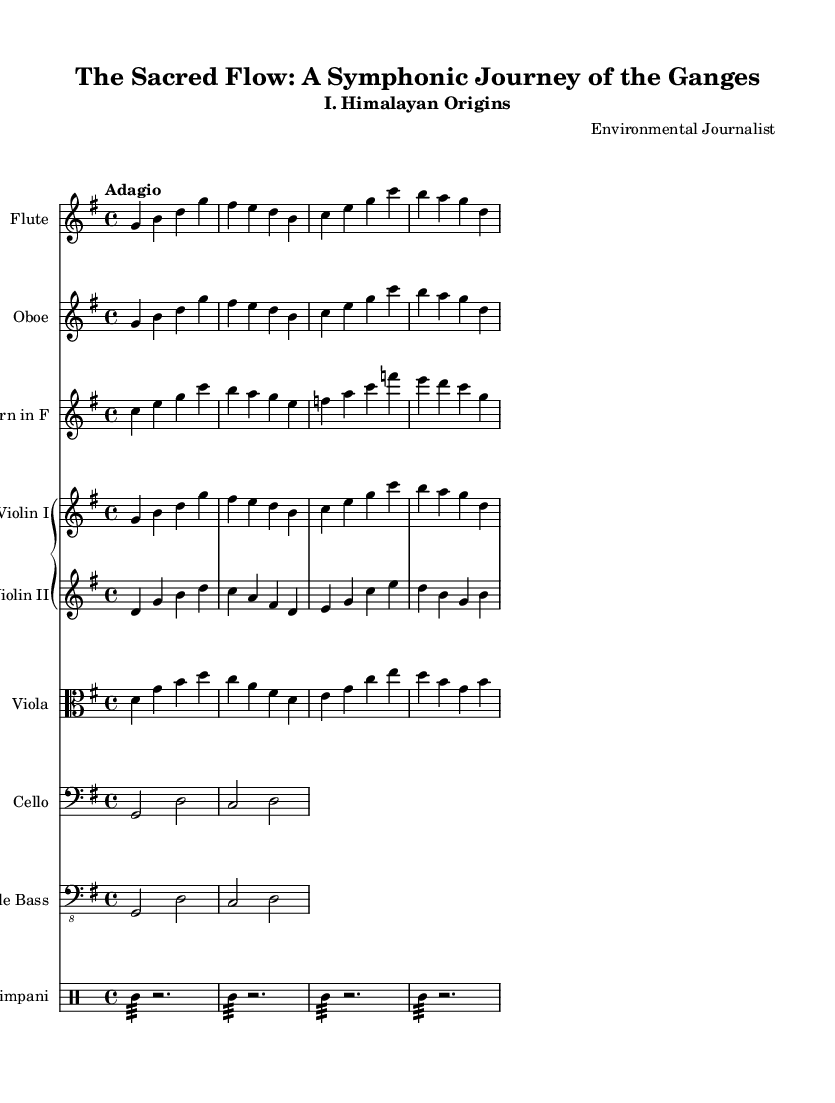What is the key signature of this music? The key signature is indicated by the number of sharps or flats at the beginning of the staff. In this case, there is one sharp (F#), which identifies the piece as being in G major.
Answer: G major What is the time signature of this music? The time signature is found at the beginning of the music; it appears as a fraction. Here, it is 4 over 4, which denotes the piece is in common time.
Answer: 4/4 What is the tempo marking of this piece? The tempo marking is typically indicated above the staff. In this score, it is labeled as "Adagio," suggesting a slow pace for the music.
Answer: Adagio How many main instrumental sections are there in this piece? By counting the different staves under the score, we can identify that there are eight distinct instrumental sections: Flute, Oboe, Horn in F, Violin I, Violin II, Viola, Cello, and Double Bass, along with a Timpani section.
Answer: Eight Which instrument is playing the theme in the first section? The theme is typically presented in the upper woodwinds or strings at the beginning. In the first section, both the Flute and Oboe play a similar melodic line, indicating they share the theme.
Answer: Flute and Oboe What is the role of the Timpani in this symphony? Timpani often provide rhythmic support and accentuate climactic moments within the music. In the provided score, the Timpani's repeated rhythmic pattern indicates its role in enhancing the overall dynamic and dramatic effects of the symphony.
Answer: Rhythmic support 